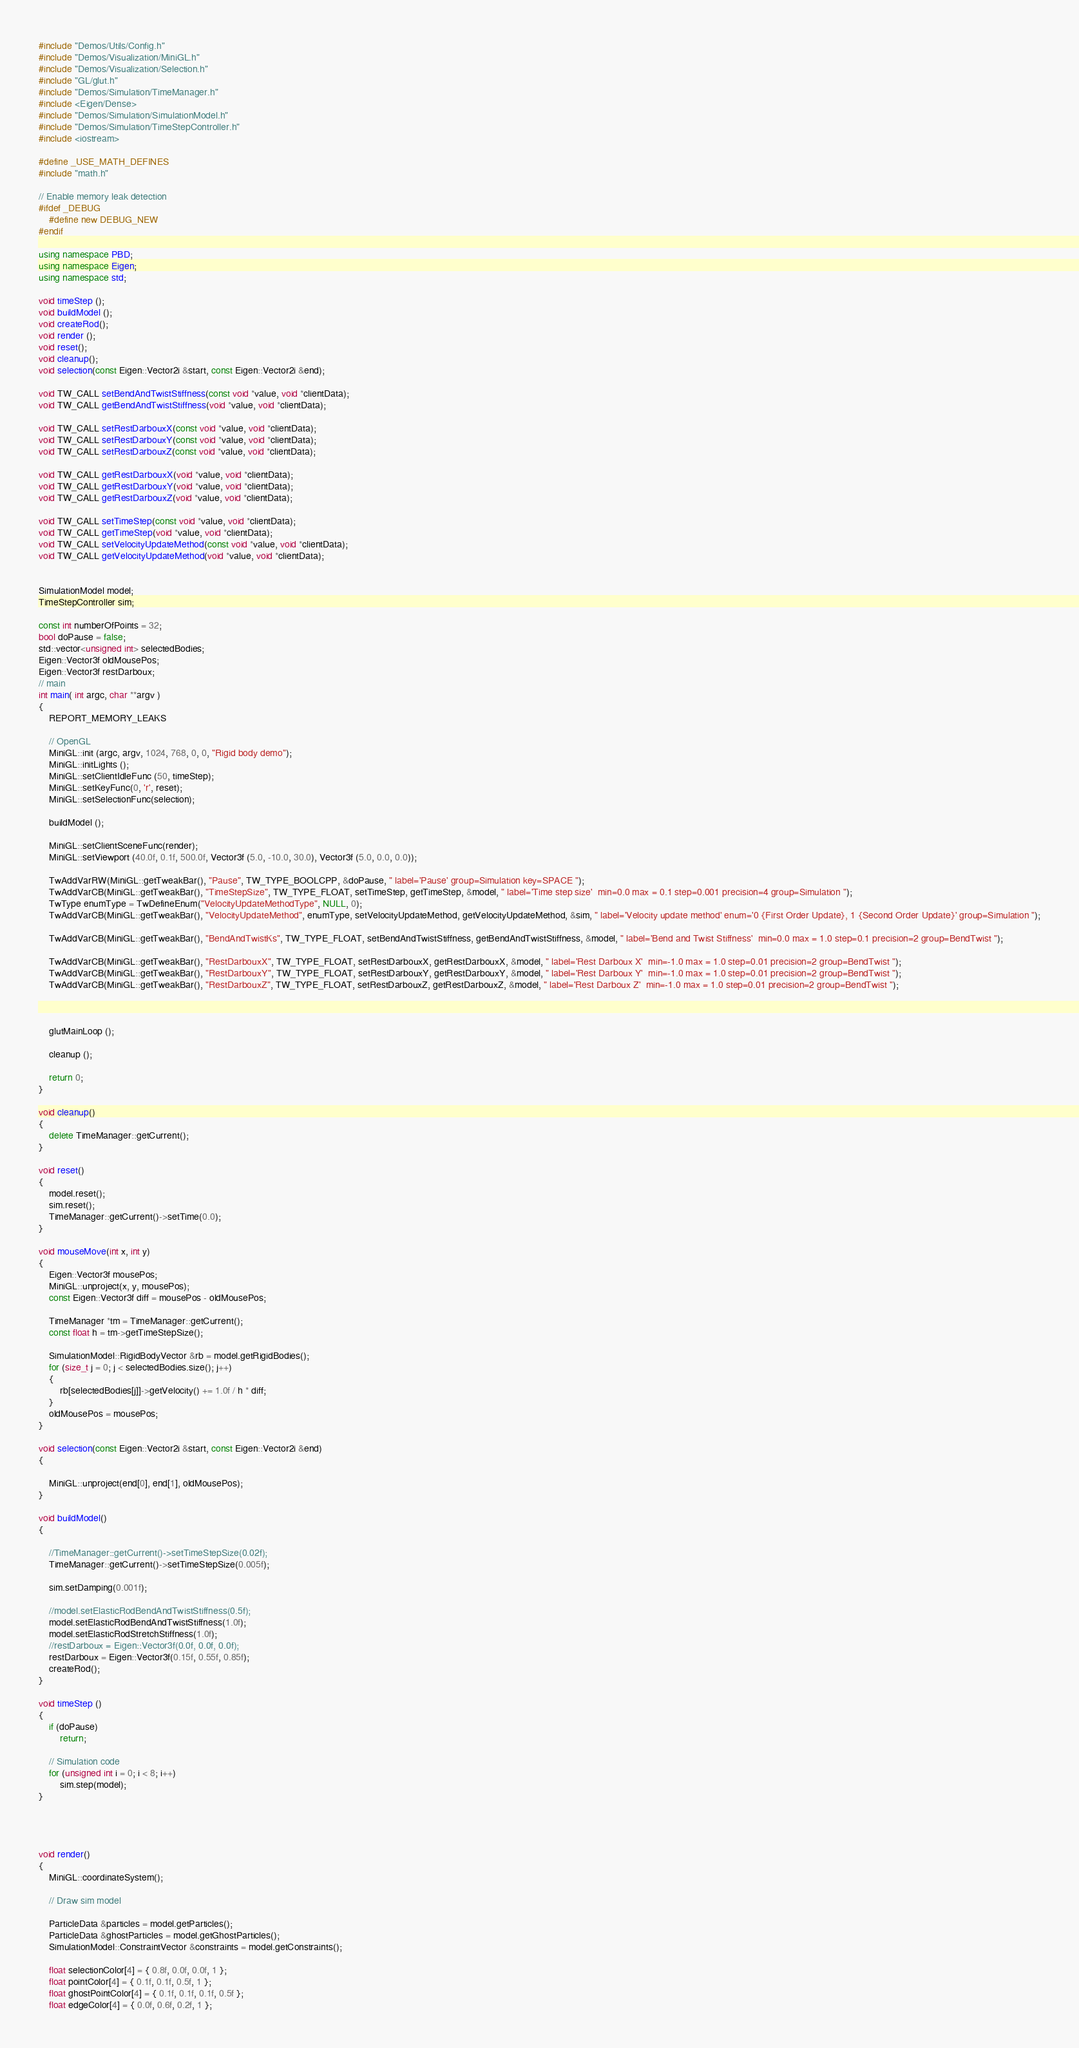<code> <loc_0><loc_0><loc_500><loc_500><_C++_>#include "Demos/Utils/Config.h"
#include "Demos/Visualization/MiniGL.h"
#include "Demos/Visualization/Selection.h"
#include "GL/glut.h"
#include "Demos/Simulation/TimeManager.h"
#include <Eigen/Dense>
#include "Demos/Simulation/SimulationModel.h"
#include "Demos/Simulation/TimeStepController.h"
#include <iostream>

#define _USE_MATH_DEFINES
#include "math.h"

// Enable memory leak detection
#ifdef _DEBUG
	#define new DEBUG_NEW 
#endif

using namespace PBD;
using namespace Eigen;
using namespace std;

void timeStep ();
void buildModel ();
void createRod();
void render ();
void reset();
void cleanup();
void selection(const Eigen::Vector2i &start, const Eigen::Vector2i &end);

void TW_CALL setBendAndTwistStiffness(const void *value, void *clientData);
void TW_CALL getBendAndTwistStiffness(void *value, void *clientData);

void TW_CALL setRestDarbouxX(const void *value, void *clientData);
void TW_CALL setRestDarbouxY(const void *value, void *clientData);
void TW_CALL setRestDarbouxZ(const void *value, void *clientData);

void TW_CALL getRestDarbouxX(void *value, void *clientData);
void TW_CALL getRestDarbouxY(void *value, void *clientData);
void TW_CALL getRestDarbouxZ(void *value, void *clientData);

void TW_CALL setTimeStep(const void *value, void *clientData);
void TW_CALL getTimeStep(void *value, void *clientData);
void TW_CALL setVelocityUpdateMethod(const void *value, void *clientData);
void TW_CALL getVelocityUpdateMethod(void *value, void *clientData);


SimulationModel model;
TimeStepController sim;

const int numberOfPoints = 32;
bool doPause = false;
std::vector<unsigned int> selectedBodies;
Eigen::Vector3f oldMousePos;
Eigen::Vector3f restDarboux;
// main 
int main( int argc, char **argv )
{
	REPORT_MEMORY_LEAKS

	// OpenGL
	MiniGL::init (argc, argv, 1024, 768, 0, 0, "Rigid body demo");
	MiniGL::initLights ();
	MiniGL::setClientIdleFunc (50, timeStep);		
	MiniGL::setKeyFunc(0, 'r', reset);
	MiniGL::setSelectionFunc(selection);

	buildModel ();

	MiniGL::setClientSceneFunc(render);			
	MiniGL::setViewport (40.0f, 0.1f, 500.0f, Vector3f (5.0, -10.0, 30.0), Vector3f (5.0, 0.0, 0.0));

	TwAddVarRW(MiniGL::getTweakBar(), "Pause", TW_TYPE_BOOLCPP, &doPause, " label='Pause' group=Simulation key=SPACE ");
	TwAddVarCB(MiniGL::getTweakBar(), "TimeStepSize", TW_TYPE_FLOAT, setTimeStep, getTimeStep, &model, " label='Time step size'  min=0.0 max = 0.1 step=0.001 precision=4 group=Simulation ");
	TwType enumType = TwDefineEnum("VelocityUpdateMethodType", NULL, 0);
	TwAddVarCB(MiniGL::getTweakBar(), "VelocityUpdateMethod", enumType, setVelocityUpdateMethod, getVelocityUpdateMethod, &sim, " label='Velocity update method' enum='0 {First Order Update}, 1 {Second Order Update}' group=Simulation ");

	TwAddVarCB(MiniGL::getTweakBar(), "BendAndTwistKs", TW_TYPE_FLOAT, setBendAndTwistStiffness, getBendAndTwistStiffness, &model, " label='Bend and Twist Stiffness'  min=0.0 max = 1.0 step=0.1 precision=2 group=BendTwist ");

	TwAddVarCB(MiniGL::getTweakBar(), "RestDarbouxX", TW_TYPE_FLOAT, setRestDarbouxX, getRestDarbouxX, &model, " label='Rest Darboux X'  min=-1.0 max = 1.0 step=0.01 precision=2 group=BendTwist ");
	TwAddVarCB(MiniGL::getTweakBar(), "RestDarbouxY", TW_TYPE_FLOAT, setRestDarbouxY, getRestDarbouxY, &model, " label='Rest Darboux Y'  min=-1.0 max = 1.0 step=0.01 precision=2 group=BendTwist ");
	TwAddVarCB(MiniGL::getTweakBar(), "RestDarbouxZ", TW_TYPE_FLOAT, setRestDarbouxZ, getRestDarbouxZ, &model, " label='Rest Darboux Z'  min=-1.0 max = 1.0 step=0.01 precision=2 group=BendTwist ");



	glutMainLoop ();	

	cleanup ();
	
	return 0;
}

void cleanup()
{
	delete TimeManager::getCurrent();
}

void reset()
{
	model.reset();
	sim.reset();
	TimeManager::getCurrent()->setTime(0.0);
}

void mouseMove(int x, int y)
{
	Eigen::Vector3f mousePos;
	MiniGL::unproject(x, y, mousePos);
	const Eigen::Vector3f diff = mousePos - oldMousePos;

	TimeManager *tm = TimeManager::getCurrent();
	const float h = tm->getTimeStepSize();

	SimulationModel::RigidBodyVector &rb = model.getRigidBodies();
	for (size_t j = 0; j < selectedBodies.size(); j++)
	{
		rb[selectedBodies[j]]->getVelocity() += 1.0f / h * diff;
	}
	oldMousePos = mousePos;
}

void selection(const Eigen::Vector2i &start, const Eigen::Vector2i &end)
{

 	MiniGL::unproject(end[0], end[1], oldMousePos);
}

void buildModel()
{

	//TimeManager::getCurrent()->setTimeStepSize(0.02f);
	TimeManager::getCurrent()->setTimeStepSize(0.005f);

	sim.setDamping(0.001f);

	//model.setElasticRodBendAndTwistStiffness(0.5f);
	model.setElasticRodBendAndTwistStiffness(1.0f);
	model.setElasticRodStretchStiffness(1.0f);
	//restDarboux = Eigen::Vector3f(0.0f, 0.0f, 0.0f);
	restDarboux = Eigen::Vector3f(0.15f, 0.55f, 0.85f);
	createRod();
}

void timeStep ()
{
	if (doPause)
		return;

	// Simulation code
	for (unsigned int i = 0; i < 8; i++)
		sim.step(model);
}




void render()
{
	MiniGL::coordinateSystem();

	// Draw sim model

	ParticleData &particles = model.getParticles();
	ParticleData &ghostParticles = model.getGhostParticles();
	SimulationModel::ConstraintVector &constraints = model.getConstraints();

	float selectionColor[4] = { 0.8f, 0.0f, 0.0f, 1 };
	float pointColor[4] = { 0.1f, 0.1f, 0.5f, 1 };
	float ghostPointColor[4] = { 0.1f, 0.1f, 0.1f, 0.5f };
	float edgeColor[4] = { 0.0f, 0.6f, 0.2f, 1 };
</code> 